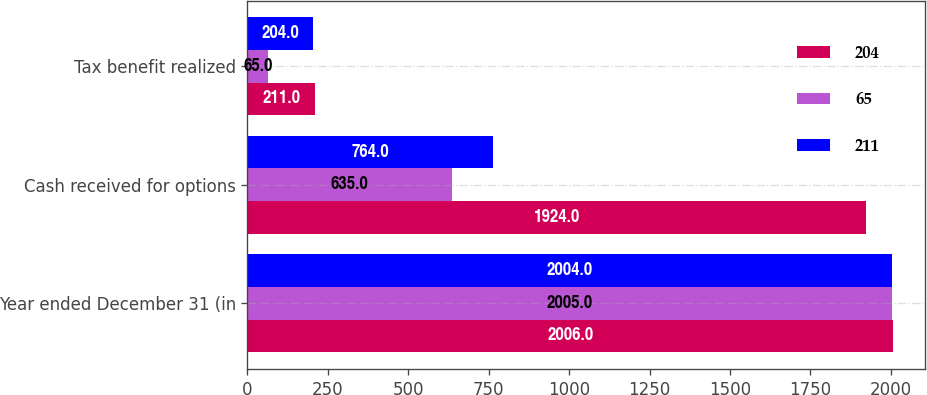Convert chart to OTSL. <chart><loc_0><loc_0><loc_500><loc_500><stacked_bar_chart><ecel><fcel>Year ended December 31 (in<fcel>Cash received for options<fcel>Tax benefit realized<nl><fcel>204<fcel>2006<fcel>1924<fcel>211<nl><fcel>65<fcel>2005<fcel>635<fcel>65<nl><fcel>211<fcel>2004<fcel>764<fcel>204<nl></chart> 